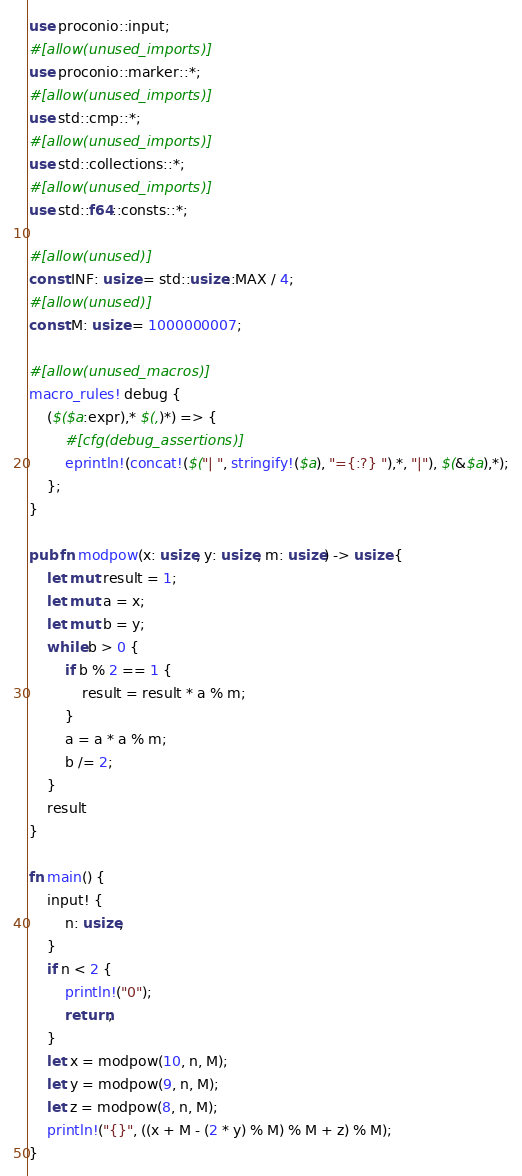<code> <loc_0><loc_0><loc_500><loc_500><_Rust_>use proconio::input;
#[allow(unused_imports)]
use proconio::marker::*;
#[allow(unused_imports)]
use std::cmp::*;
#[allow(unused_imports)]
use std::collections::*;
#[allow(unused_imports)]
use std::f64::consts::*;

#[allow(unused)]
const INF: usize = std::usize::MAX / 4;
#[allow(unused)]
const M: usize = 1000000007;

#[allow(unused_macros)]
macro_rules! debug {
    ($($a:expr),* $(,)*) => {
        #[cfg(debug_assertions)]
        eprintln!(concat!($("| ", stringify!($a), "={:?} "),*, "|"), $(&$a),*);
    };
}

pub fn modpow(x: usize, y: usize, m: usize) -> usize {
    let mut result = 1;
    let mut a = x;
    let mut b = y;
    while b > 0 {
        if b % 2 == 1 {
            result = result * a % m;
        }
        a = a * a % m;
        b /= 2;
    }
    result
}

fn main() {
    input! {
        n: usize,
    }
    if n < 2 {
        println!("0");
        return;
    }
    let x = modpow(10, n, M);
    let y = modpow(9, n, M);
    let z = modpow(8, n, M);
    println!("{}", ((x + M - (2 * y) % M) % M + z) % M);
}
</code> 